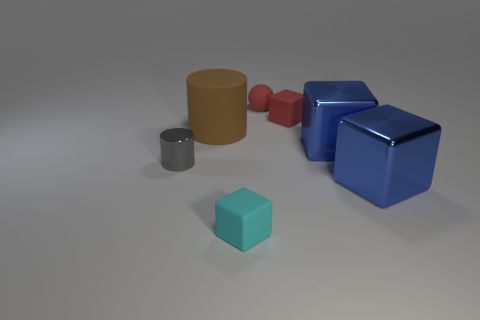Is the material of the small red block the same as the small gray thing?
Offer a terse response. No. There is another thing that is the same shape as the large rubber object; what is its color?
Your answer should be compact. Gray. Do the cube behind the big brown matte cylinder and the tiny rubber sphere have the same color?
Provide a succinct answer. Yes. What is the shape of the small thing that is the same color as the tiny ball?
Ensure brevity in your answer.  Cube. What number of red objects are made of the same material as the brown cylinder?
Your answer should be very brief. 2. There is a big brown cylinder; what number of cyan objects are behind it?
Offer a terse response. 0. The gray shiny object is what size?
Offer a terse response. Small. The matte ball that is the same size as the cyan block is what color?
Your response must be concise. Red. Are there any tiny objects that have the same color as the small ball?
Offer a very short reply. Yes. What is the material of the gray cylinder?
Make the answer very short. Metal. 